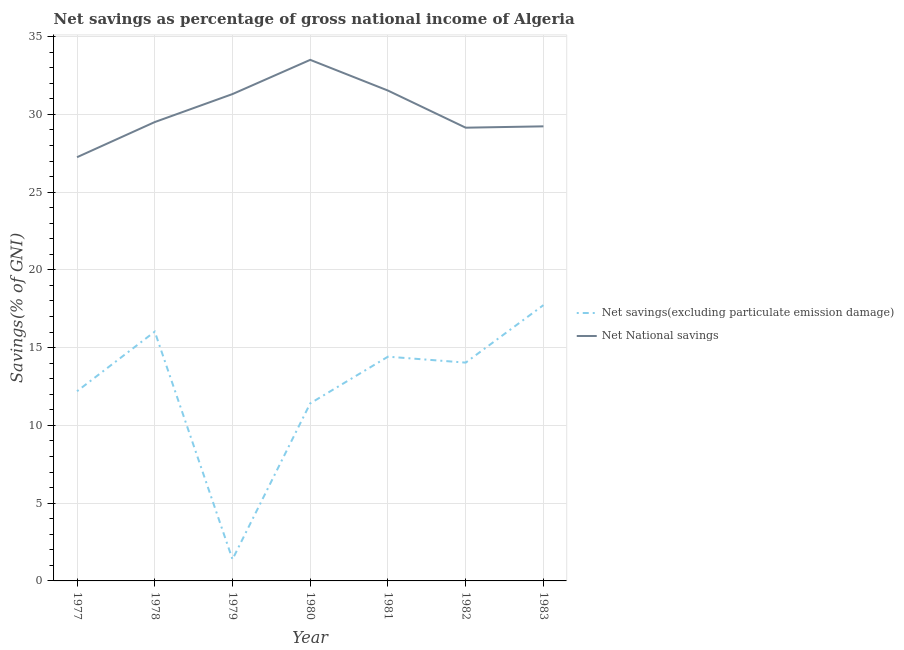How many different coloured lines are there?
Offer a terse response. 2. Does the line corresponding to net national savings intersect with the line corresponding to net savings(excluding particulate emission damage)?
Make the answer very short. No. What is the net national savings in 1980?
Offer a very short reply. 33.51. Across all years, what is the maximum net national savings?
Give a very brief answer. 33.51. Across all years, what is the minimum net national savings?
Ensure brevity in your answer.  27.25. In which year was the net national savings maximum?
Your response must be concise. 1980. In which year was the net national savings minimum?
Give a very brief answer. 1977. What is the total net savings(excluding particulate emission damage) in the graph?
Your answer should be compact. 87.23. What is the difference between the net savings(excluding particulate emission damage) in 1980 and that in 1982?
Your response must be concise. -2.62. What is the difference between the net savings(excluding particulate emission damage) in 1979 and the net national savings in 1980?
Provide a succinct answer. -32.12. What is the average net savings(excluding particulate emission damage) per year?
Make the answer very short. 12.46. In the year 1978, what is the difference between the net national savings and net savings(excluding particulate emission damage)?
Ensure brevity in your answer.  13.48. What is the ratio of the net savings(excluding particulate emission damage) in 1980 to that in 1982?
Provide a short and direct response. 0.81. What is the difference between the highest and the second highest net national savings?
Provide a short and direct response. 1.98. What is the difference between the highest and the lowest net savings(excluding particulate emission damage)?
Make the answer very short. 16.35. In how many years, is the net savings(excluding particulate emission damage) greater than the average net savings(excluding particulate emission damage) taken over all years?
Keep it short and to the point. 4. Is the sum of the net national savings in 1979 and 1981 greater than the maximum net savings(excluding particulate emission damage) across all years?
Give a very brief answer. Yes. Does the net national savings monotonically increase over the years?
Keep it short and to the point. No. Is the net savings(excluding particulate emission damage) strictly greater than the net national savings over the years?
Offer a very short reply. No. How many lines are there?
Your answer should be compact. 2. How many years are there in the graph?
Provide a short and direct response. 7. How many legend labels are there?
Give a very brief answer. 2. How are the legend labels stacked?
Offer a very short reply. Vertical. What is the title of the graph?
Ensure brevity in your answer.  Net savings as percentage of gross national income of Algeria. Does "Manufacturing industries and construction" appear as one of the legend labels in the graph?
Provide a succinct answer. No. What is the label or title of the Y-axis?
Offer a terse response. Savings(% of GNI). What is the Savings(% of GNI) of Net savings(excluding particulate emission damage) in 1977?
Offer a terse response. 12.2. What is the Savings(% of GNI) in Net National savings in 1977?
Provide a succinct answer. 27.25. What is the Savings(% of GNI) of Net savings(excluding particulate emission damage) in 1978?
Give a very brief answer. 16.03. What is the Savings(% of GNI) of Net National savings in 1978?
Keep it short and to the point. 29.51. What is the Savings(% of GNI) in Net savings(excluding particulate emission damage) in 1979?
Ensure brevity in your answer.  1.39. What is the Savings(% of GNI) in Net National savings in 1979?
Provide a succinct answer. 31.31. What is the Savings(% of GNI) of Net savings(excluding particulate emission damage) in 1980?
Your answer should be very brief. 11.42. What is the Savings(% of GNI) of Net National savings in 1980?
Give a very brief answer. 33.51. What is the Savings(% of GNI) in Net savings(excluding particulate emission damage) in 1981?
Offer a very short reply. 14.42. What is the Savings(% of GNI) in Net National savings in 1981?
Give a very brief answer. 31.53. What is the Savings(% of GNI) in Net savings(excluding particulate emission damage) in 1982?
Your answer should be very brief. 14.04. What is the Savings(% of GNI) in Net National savings in 1982?
Your answer should be compact. 29.14. What is the Savings(% of GNI) in Net savings(excluding particulate emission damage) in 1983?
Your answer should be very brief. 17.73. What is the Savings(% of GNI) in Net National savings in 1983?
Your answer should be compact. 29.23. Across all years, what is the maximum Savings(% of GNI) of Net savings(excluding particulate emission damage)?
Give a very brief answer. 17.73. Across all years, what is the maximum Savings(% of GNI) of Net National savings?
Your answer should be very brief. 33.51. Across all years, what is the minimum Savings(% of GNI) of Net savings(excluding particulate emission damage)?
Provide a short and direct response. 1.39. Across all years, what is the minimum Savings(% of GNI) in Net National savings?
Keep it short and to the point. 27.25. What is the total Savings(% of GNI) in Net savings(excluding particulate emission damage) in the graph?
Offer a terse response. 87.23. What is the total Savings(% of GNI) of Net National savings in the graph?
Ensure brevity in your answer.  211.47. What is the difference between the Savings(% of GNI) of Net savings(excluding particulate emission damage) in 1977 and that in 1978?
Your answer should be very brief. -3.83. What is the difference between the Savings(% of GNI) in Net National savings in 1977 and that in 1978?
Offer a terse response. -2.26. What is the difference between the Savings(% of GNI) in Net savings(excluding particulate emission damage) in 1977 and that in 1979?
Your response must be concise. 10.81. What is the difference between the Savings(% of GNI) of Net National savings in 1977 and that in 1979?
Give a very brief answer. -4.06. What is the difference between the Savings(% of GNI) of Net savings(excluding particulate emission damage) in 1977 and that in 1980?
Your answer should be compact. 0.78. What is the difference between the Savings(% of GNI) in Net National savings in 1977 and that in 1980?
Your answer should be compact. -6.26. What is the difference between the Savings(% of GNI) of Net savings(excluding particulate emission damage) in 1977 and that in 1981?
Ensure brevity in your answer.  -2.22. What is the difference between the Savings(% of GNI) of Net National savings in 1977 and that in 1981?
Keep it short and to the point. -4.28. What is the difference between the Savings(% of GNI) of Net savings(excluding particulate emission damage) in 1977 and that in 1982?
Your answer should be compact. -1.84. What is the difference between the Savings(% of GNI) in Net National savings in 1977 and that in 1982?
Make the answer very short. -1.9. What is the difference between the Savings(% of GNI) in Net savings(excluding particulate emission damage) in 1977 and that in 1983?
Offer a very short reply. -5.54. What is the difference between the Savings(% of GNI) of Net National savings in 1977 and that in 1983?
Offer a terse response. -1.98. What is the difference between the Savings(% of GNI) in Net savings(excluding particulate emission damage) in 1978 and that in 1979?
Provide a succinct answer. 14.64. What is the difference between the Savings(% of GNI) in Net National savings in 1978 and that in 1979?
Ensure brevity in your answer.  -1.8. What is the difference between the Savings(% of GNI) of Net savings(excluding particulate emission damage) in 1978 and that in 1980?
Your answer should be compact. 4.61. What is the difference between the Savings(% of GNI) in Net National savings in 1978 and that in 1980?
Your response must be concise. -4. What is the difference between the Savings(% of GNI) of Net savings(excluding particulate emission damage) in 1978 and that in 1981?
Provide a short and direct response. 1.61. What is the difference between the Savings(% of GNI) of Net National savings in 1978 and that in 1981?
Keep it short and to the point. -2.02. What is the difference between the Savings(% of GNI) of Net savings(excluding particulate emission damage) in 1978 and that in 1982?
Keep it short and to the point. 1.99. What is the difference between the Savings(% of GNI) in Net National savings in 1978 and that in 1982?
Your answer should be very brief. 0.36. What is the difference between the Savings(% of GNI) in Net savings(excluding particulate emission damage) in 1978 and that in 1983?
Give a very brief answer. -1.7. What is the difference between the Savings(% of GNI) in Net National savings in 1978 and that in 1983?
Provide a succinct answer. 0.28. What is the difference between the Savings(% of GNI) in Net savings(excluding particulate emission damage) in 1979 and that in 1980?
Ensure brevity in your answer.  -10.03. What is the difference between the Savings(% of GNI) in Net National savings in 1979 and that in 1980?
Offer a terse response. -2.2. What is the difference between the Savings(% of GNI) in Net savings(excluding particulate emission damage) in 1979 and that in 1981?
Provide a short and direct response. -13.03. What is the difference between the Savings(% of GNI) of Net National savings in 1979 and that in 1981?
Offer a very short reply. -0.22. What is the difference between the Savings(% of GNI) in Net savings(excluding particulate emission damage) in 1979 and that in 1982?
Your response must be concise. -12.65. What is the difference between the Savings(% of GNI) of Net National savings in 1979 and that in 1982?
Provide a succinct answer. 2.16. What is the difference between the Savings(% of GNI) in Net savings(excluding particulate emission damage) in 1979 and that in 1983?
Ensure brevity in your answer.  -16.35. What is the difference between the Savings(% of GNI) in Net National savings in 1979 and that in 1983?
Offer a very short reply. 2.08. What is the difference between the Savings(% of GNI) in Net savings(excluding particulate emission damage) in 1980 and that in 1981?
Give a very brief answer. -3. What is the difference between the Savings(% of GNI) of Net National savings in 1980 and that in 1981?
Your answer should be compact. 1.98. What is the difference between the Savings(% of GNI) in Net savings(excluding particulate emission damage) in 1980 and that in 1982?
Offer a very short reply. -2.62. What is the difference between the Savings(% of GNI) of Net National savings in 1980 and that in 1982?
Make the answer very short. 4.36. What is the difference between the Savings(% of GNI) of Net savings(excluding particulate emission damage) in 1980 and that in 1983?
Provide a short and direct response. -6.32. What is the difference between the Savings(% of GNI) in Net National savings in 1980 and that in 1983?
Your answer should be very brief. 4.28. What is the difference between the Savings(% of GNI) of Net savings(excluding particulate emission damage) in 1981 and that in 1982?
Your answer should be very brief. 0.38. What is the difference between the Savings(% of GNI) of Net National savings in 1981 and that in 1982?
Provide a succinct answer. 2.39. What is the difference between the Savings(% of GNI) of Net savings(excluding particulate emission damage) in 1981 and that in 1983?
Your response must be concise. -3.31. What is the difference between the Savings(% of GNI) in Net National savings in 1981 and that in 1983?
Offer a terse response. 2.3. What is the difference between the Savings(% of GNI) of Net savings(excluding particulate emission damage) in 1982 and that in 1983?
Keep it short and to the point. -3.7. What is the difference between the Savings(% of GNI) of Net National savings in 1982 and that in 1983?
Keep it short and to the point. -0.09. What is the difference between the Savings(% of GNI) of Net savings(excluding particulate emission damage) in 1977 and the Savings(% of GNI) of Net National savings in 1978?
Your answer should be very brief. -17.31. What is the difference between the Savings(% of GNI) in Net savings(excluding particulate emission damage) in 1977 and the Savings(% of GNI) in Net National savings in 1979?
Make the answer very short. -19.11. What is the difference between the Savings(% of GNI) of Net savings(excluding particulate emission damage) in 1977 and the Savings(% of GNI) of Net National savings in 1980?
Ensure brevity in your answer.  -21.31. What is the difference between the Savings(% of GNI) of Net savings(excluding particulate emission damage) in 1977 and the Savings(% of GNI) of Net National savings in 1981?
Offer a terse response. -19.33. What is the difference between the Savings(% of GNI) of Net savings(excluding particulate emission damage) in 1977 and the Savings(% of GNI) of Net National savings in 1982?
Provide a succinct answer. -16.95. What is the difference between the Savings(% of GNI) in Net savings(excluding particulate emission damage) in 1977 and the Savings(% of GNI) in Net National savings in 1983?
Offer a terse response. -17.03. What is the difference between the Savings(% of GNI) of Net savings(excluding particulate emission damage) in 1978 and the Savings(% of GNI) of Net National savings in 1979?
Ensure brevity in your answer.  -15.28. What is the difference between the Savings(% of GNI) of Net savings(excluding particulate emission damage) in 1978 and the Savings(% of GNI) of Net National savings in 1980?
Give a very brief answer. -17.48. What is the difference between the Savings(% of GNI) in Net savings(excluding particulate emission damage) in 1978 and the Savings(% of GNI) in Net National savings in 1981?
Give a very brief answer. -15.5. What is the difference between the Savings(% of GNI) of Net savings(excluding particulate emission damage) in 1978 and the Savings(% of GNI) of Net National savings in 1982?
Ensure brevity in your answer.  -13.11. What is the difference between the Savings(% of GNI) of Net savings(excluding particulate emission damage) in 1978 and the Savings(% of GNI) of Net National savings in 1983?
Make the answer very short. -13.2. What is the difference between the Savings(% of GNI) of Net savings(excluding particulate emission damage) in 1979 and the Savings(% of GNI) of Net National savings in 1980?
Provide a short and direct response. -32.12. What is the difference between the Savings(% of GNI) of Net savings(excluding particulate emission damage) in 1979 and the Savings(% of GNI) of Net National savings in 1981?
Your response must be concise. -30.14. What is the difference between the Savings(% of GNI) of Net savings(excluding particulate emission damage) in 1979 and the Savings(% of GNI) of Net National savings in 1982?
Ensure brevity in your answer.  -27.76. What is the difference between the Savings(% of GNI) of Net savings(excluding particulate emission damage) in 1979 and the Savings(% of GNI) of Net National savings in 1983?
Keep it short and to the point. -27.84. What is the difference between the Savings(% of GNI) of Net savings(excluding particulate emission damage) in 1980 and the Savings(% of GNI) of Net National savings in 1981?
Ensure brevity in your answer.  -20.11. What is the difference between the Savings(% of GNI) in Net savings(excluding particulate emission damage) in 1980 and the Savings(% of GNI) in Net National savings in 1982?
Ensure brevity in your answer.  -17.73. What is the difference between the Savings(% of GNI) of Net savings(excluding particulate emission damage) in 1980 and the Savings(% of GNI) of Net National savings in 1983?
Ensure brevity in your answer.  -17.81. What is the difference between the Savings(% of GNI) of Net savings(excluding particulate emission damage) in 1981 and the Savings(% of GNI) of Net National savings in 1982?
Provide a succinct answer. -14.72. What is the difference between the Savings(% of GNI) in Net savings(excluding particulate emission damage) in 1981 and the Savings(% of GNI) in Net National savings in 1983?
Your response must be concise. -14.81. What is the difference between the Savings(% of GNI) of Net savings(excluding particulate emission damage) in 1982 and the Savings(% of GNI) of Net National savings in 1983?
Keep it short and to the point. -15.19. What is the average Savings(% of GNI) in Net savings(excluding particulate emission damage) per year?
Offer a very short reply. 12.46. What is the average Savings(% of GNI) in Net National savings per year?
Make the answer very short. 30.21. In the year 1977, what is the difference between the Savings(% of GNI) of Net savings(excluding particulate emission damage) and Savings(% of GNI) of Net National savings?
Keep it short and to the point. -15.05. In the year 1978, what is the difference between the Savings(% of GNI) in Net savings(excluding particulate emission damage) and Savings(% of GNI) in Net National savings?
Your answer should be very brief. -13.48. In the year 1979, what is the difference between the Savings(% of GNI) of Net savings(excluding particulate emission damage) and Savings(% of GNI) of Net National savings?
Ensure brevity in your answer.  -29.92. In the year 1980, what is the difference between the Savings(% of GNI) of Net savings(excluding particulate emission damage) and Savings(% of GNI) of Net National savings?
Provide a short and direct response. -22.09. In the year 1981, what is the difference between the Savings(% of GNI) in Net savings(excluding particulate emission damage) and Savings(% of GNI) in Net National savings?
Provide a short and direct response. -17.11. In the year 1982, what is the difference between the Savings(% of GNI) of Net savings(excluding particulate emission damage) and Savings(% of GNI) of Net National savings?
Make the answer very short. -15.11. In the year 1983, what is the difference between the Savings(% of GNI) of Net savings(excluding particulate emission damage) and Savings(% of GNI) of Net National savings?
Make the answer very short. -11.5. What is the ratio of the Savings(% of GNI) of Net savings(excluding particulate emission damage) in 1977 to that in 1978?
Provide a succinct answer. 0.76. What is the ratio of the Savings(% of GNI) of Net National savings in 1977 to that in 1978?
Give a very brief answer. 0.92. What is the ratio of the Savings(% of GNI) of Net savings(excluding particulate emission damage) in 1977 to that in 1979?
Make the answer very short. 8.79. What is the ratio of the Savings(% of GNI) of Net National savings in 1977 to that in 1979?
Give a very brief answer. 0.87. What is the ratio of the Savings(% of GNI) in Net savings(excluding particulate emission damage) in 1977 to that in 1980?
Offer a very short reply. 1.07. What is the ratio of the Savings(% of GNI) of Net National savings in 1977 to that in 1980?
Make the answer very short. 0.81. What is the ratio of the Savings(% of GNI) of Net savings(excluding particulate emission damage) in 1977 to that in 1981?
Give a very brief answer. 0.85. What is the ratio of the Savings(% of GNI) in Net National savings in 1977 to that in 1981?
Make the answer very short. 0.86. What is the ratio of the Savings(% of GNI) of Net savings(excluding particulate emission damage) in 1977 to that in 1982?
Offer a terse response. 0.87. What is the ratio of the Savings(% of GNI) of Net National savings in 1977 to that in 1982?
Your answer should be very brief. 0.93. What is the ratio of the Savings(% of GNI) in Net savings(excluding particulate emission damage) in 1977 to that in 1983?
Offer a very short reply. 0.69. What is the ratio of the Savings(% of GNI) of Net National savings in 1977 to that in 1983?
Provide a short and direct response. 0.93. What is the ratio of the Savings(% of GNI) of Net savings(excluding particulate emission damage) in 1978 to that in 1979?
Ensure brevity in your answer.  11.55. What is the ratio of the Savings(% of GNI) of Net National savings in 1978 to that in 1979?
Your answer should be very brief. 0.94. What is the ratio of the Savings(% of GNI) in Net savings(excluding particulate emission damage) in 1978 to that in 1980?
Ensure brevity in your answer.  1.4. What is the ratio of the Savings(% of GNI) in Net National savings in 1978 to that in 1980?
Offer a terse response. 0.88. What is the ratio of the Savings(% of GNI) in Net savings(excluding particulate emission damage) in 1978 to that in 1981?
Make the answer very short. 1.11. What is the ratio of the Savings(% of GNI) in Net National savings in 1978 to that in 1981?
Offer a terse response. 0.94. What is the ratio of the Savings(% of GNI) of Net savings(excluding particulate emission damage) in 1978 to that in 1982?
Your response must be concise. 1.14. What is the ratio of the Savings(% of GNI) in Net National savings in 1978 to that in 1982?
Ensure brevity in your answer.  1.01. What is the ratio of the Savings(% of GNI) in Net savings(excluding particulate emission damage) in 1978 to that in 1983?
Ensure brevity in your answer.  0.9. What is the ratio of the Savings(% of GNI) of Net National savings in 1978 to that in 1983?
Give a very brief answer. 1.01. What is the ratio of the Savings(% of GNI) of Net savings(excluding particulate emission damage) in 1979 to that in 1980?
Provide a succinct answer. 0.12. What is the ratio of the Savings(% of GNI) of Net National savings in 1979 to that in 1980?
Offer a terse response. 0.93. What is the ratio of the Savings(% of GNI) of Net savings(excluding particulate emission damage) in 1979 to that in 1981?
Offer a terse response. 0.1. What is the ratio of the Savings(% of GNI) in Net savings(excluding particulate emission damage) in 1979 to that in 1982?
Provide a succinct answer. 0.1. What is the ratio of the Savings(% of GNI) of Net National savings in 1979 to that in 1982?
Provide a succinct answer. 1.07. What is the ratio of the Savings(% of GNI) in Net savings(excluding particulate emission damage) in 1979 to that in 1983?
Provide a succinct answer. 0.08. What is the ratio of the Savings(% of GNI) in Net National savings in 1979 to that in 1983?
Offer a terse response. 1.07. What is the ratio of the Savings(% of GNI) in Net savings(excluding particulate emission damage) in 1980 to that in 1981?
Ensure brevity in your answer.  0.79. What is the ratio of the Savings(% of GNI) in Net National savings in 1980 to that in 1981?
Provide a short and direct response. 1.06. What is the ratio of the Savings(% of GNI) of Net savings(excluding particulate emission damage) in 1980 to that in 1982?
Make the answer very short. 0.81. What is the ratio of the Savings(% of GNI) in Net National savings in 1980 to that in 1982?
Provide a short and direct response. 1.15. What is the ratio of the Savings(% of GNI) of Net savings(excluding particulate emission damage) in 1980 to that in 1983?
Provide a succinct answer. 0.64. What is the ratio of the Savings(% of GNI) of Net National savings in 1980 to that in 1983?
Your answer should be compact. 1.15. What is the ratio of the Savings(% of GNI) in Net savings(excluding particulate emission damage) in 1981 to that in 1982?
Your response must be concise. 1.03. What is the ratio of the Savings(% of GNI) of Net National savings in 1981 to that in 1982?
Your response must be concise. 1.08. What is the ratio of the Savings(% of GNI) of Net savings(excluding particulate emission damage) in 1981 to that in 1983?
Ensure brevity in your answer.  0.81. What is the ratio of the Savings(% of GNI) of Net National savings in 1981 to that in 1983?
Give a very brief answer. 1.08. What is the ratio of the Savings(% of GNI) of Net savings(excluding particulate emission damage) in 1982 to that in 1983?
Ensure brevity in your answer.  0.79. What is the ratio of the Savings(% of GNI) in Net National savings in 1982 to that in 1983?
Ensure brevity in your answer.  1. What is the difference between the highest and the second highest Savings(% of GNI) in Net savings(excluding particulate emission damage)?
Give a very brief answer. 1.7. What is the difference between the highest and the second highest Savings(% of GNI) in Net National savings?
Provide a succinct answer. 1.98. What is the difference between the highest and the lowest Savings(% of GNI) of Net savings(excluding particulate emission damage)?
Your answer should be compact. 16.35. What is the difference between the highest and the lowest Savings(% of GNI) in Net National savings?
Your answer should be compact. 6.26. 